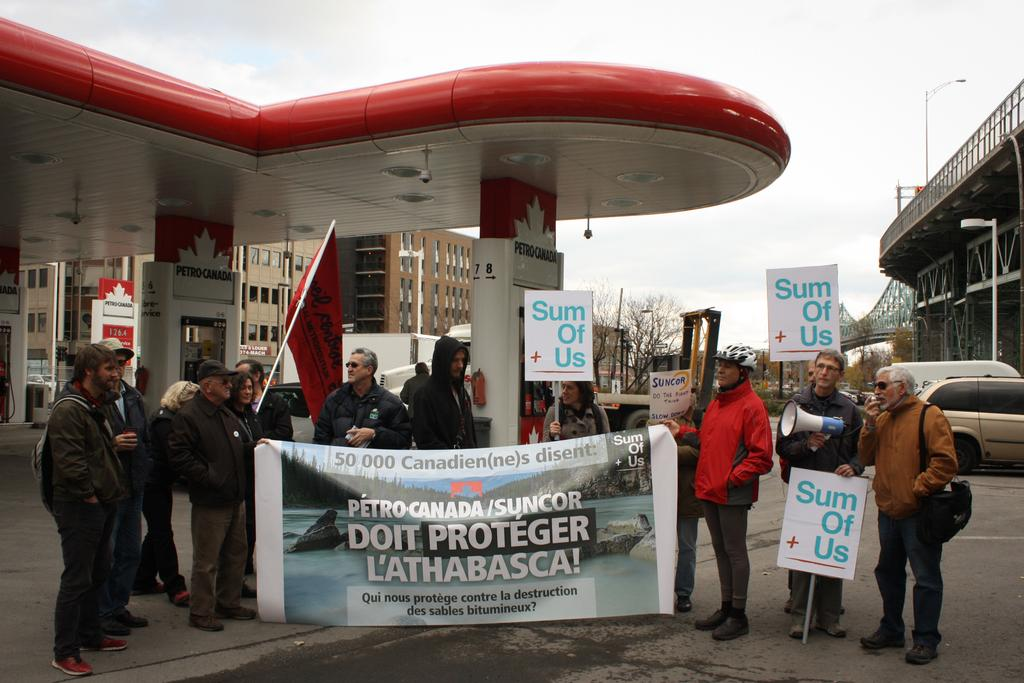What are the people in the image doing? The people in the image are standing on the roads. What are the people holding in the image? The people are holding banners in the image. What can be seen in the background of the image? There are buildings and trees visible in the image. What is the condition of the chin of the person holding the banner in the image? There is no chin visible in the image, as the people holding banners are not shown in close-up. 